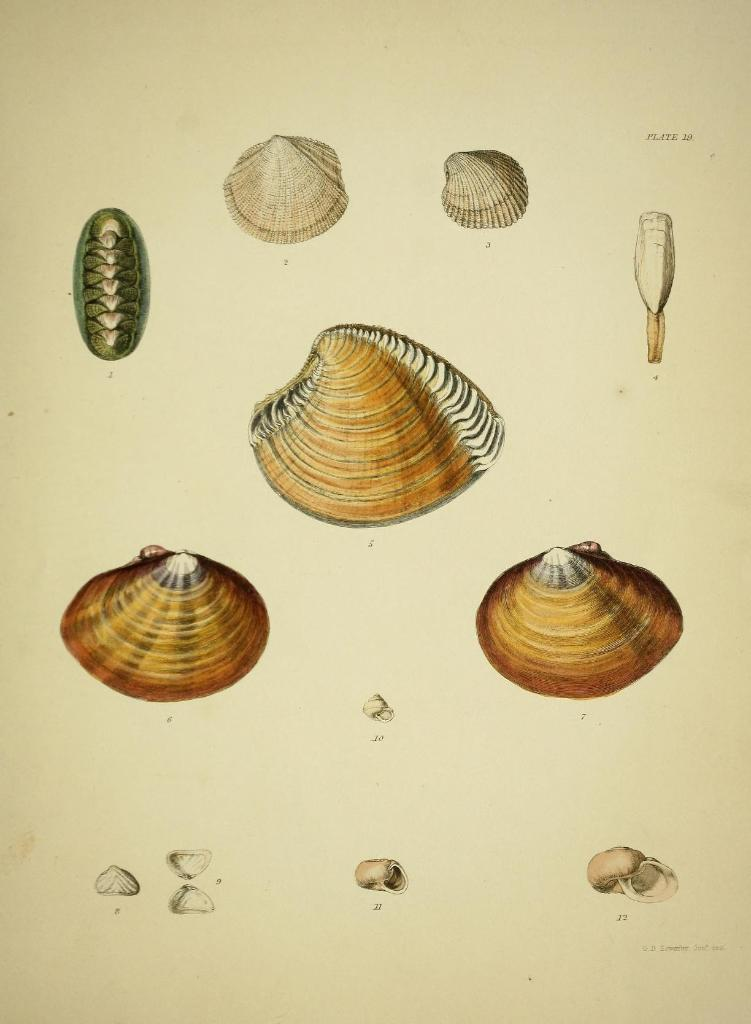What is depicted on the paper in the image? The paper contains images of shells. How many layers of cake can be seen in the image? There are no cakes present in the image; it features a paper with images of shells. What type of print is used for the shell images on the paper? The provided facts do not specify the type of print used for the shell images on the paper. 